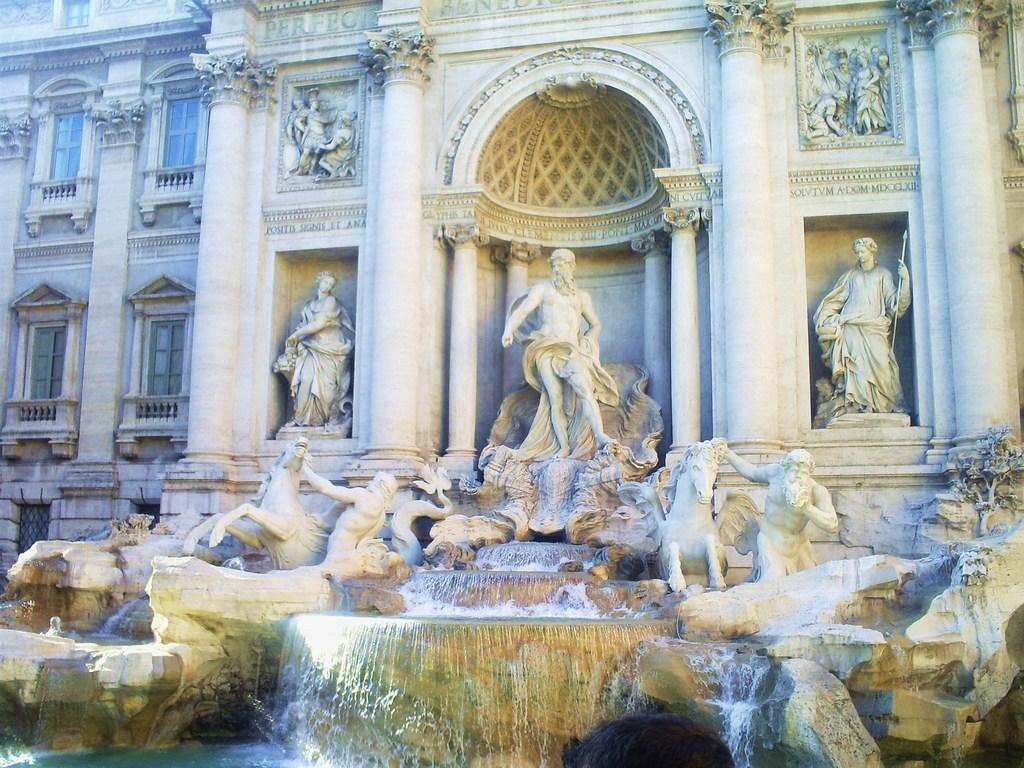What type of structure is present in the image? There is a building in the image. What decorative elements can be seen on the building? Sculptures are carved on the building. What is located at the bottom of the building? There is a fountain at the bottom of the building. How can light enter the building? There are windows on the building. What color of paint is used on the twist in the aftermath of the sculpture? There is no twist or paint mentioned in the image, and there is no aftermath depicted. 